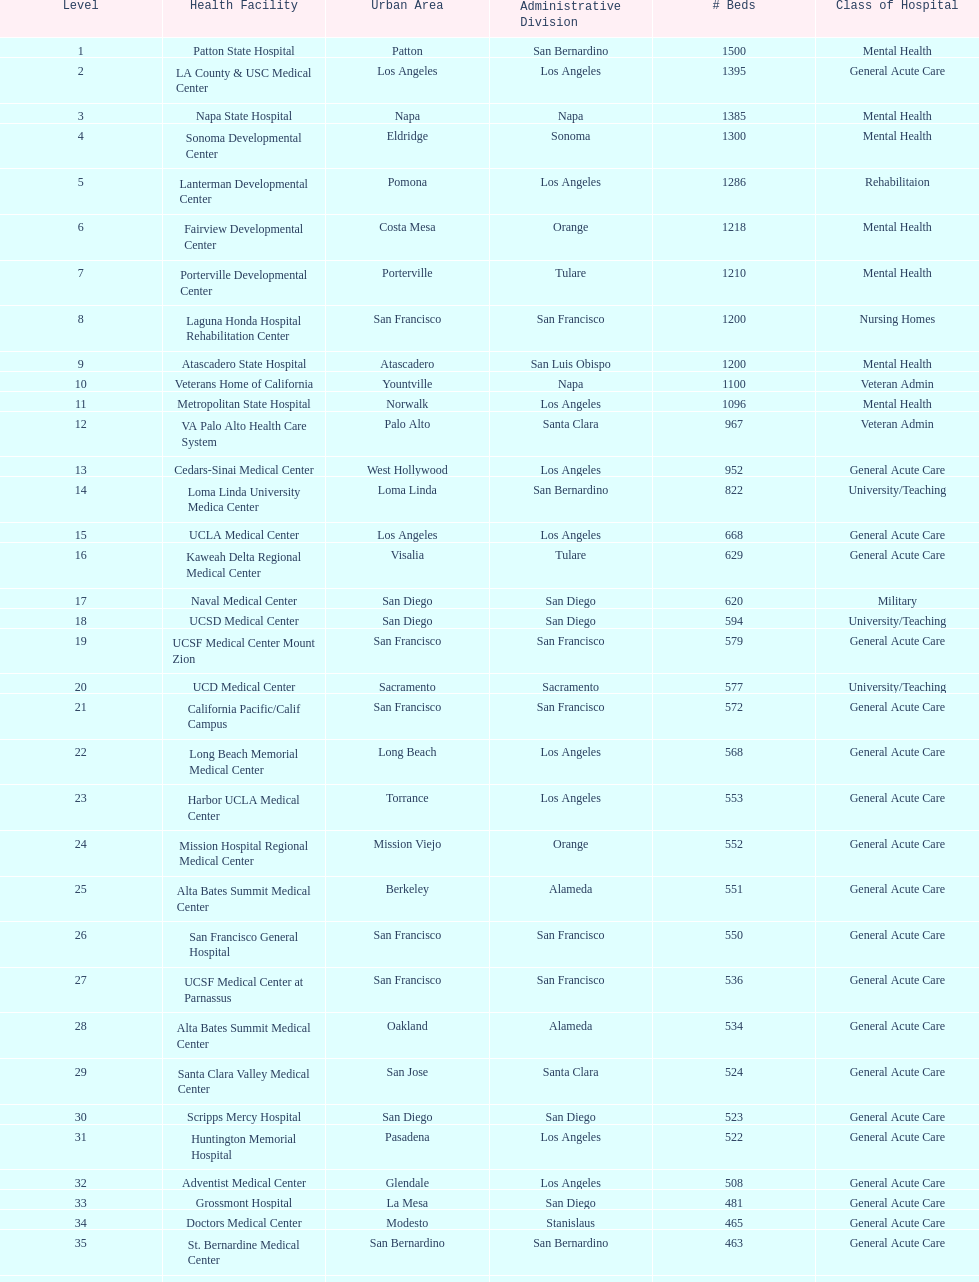How many hospitals have at least 1,000 beds? 11. 